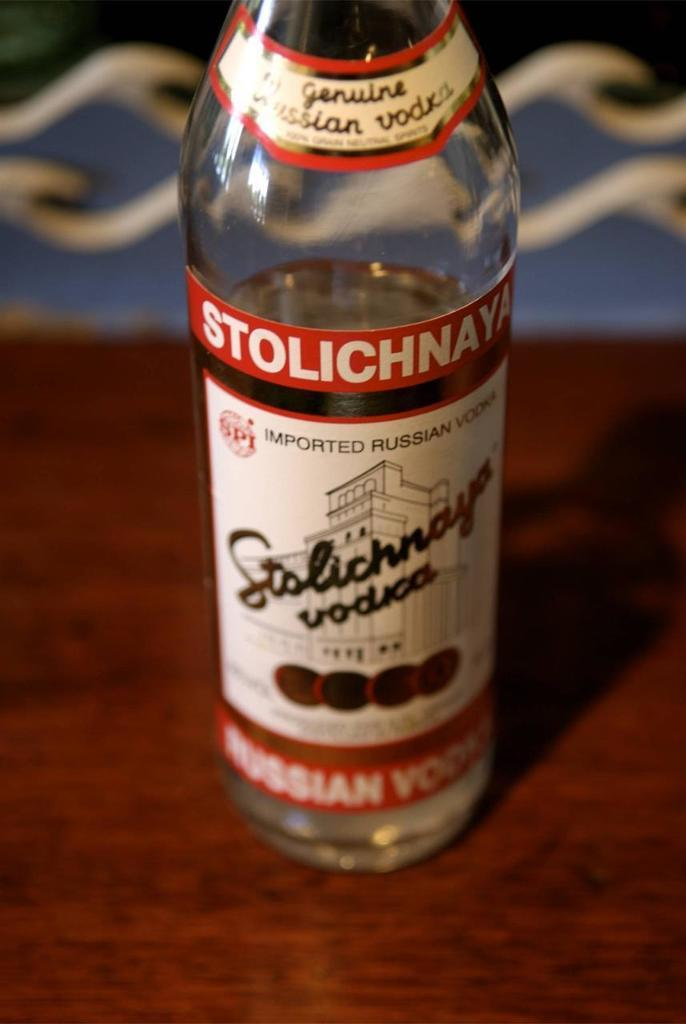<image>
Relay a brief, clear account of the picture shown. A half full bottle of Stolichnaya vodka sits on a table. 